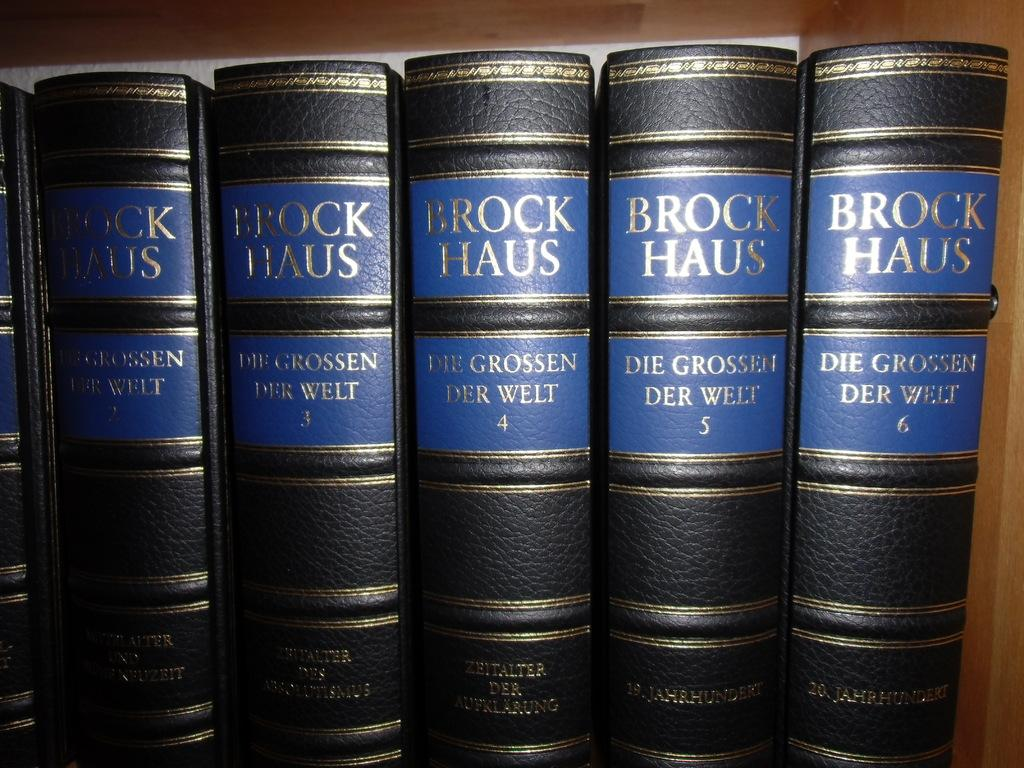<image>
Provide a brief description of the given image. some leather bound books by Brock Haus lined up together 